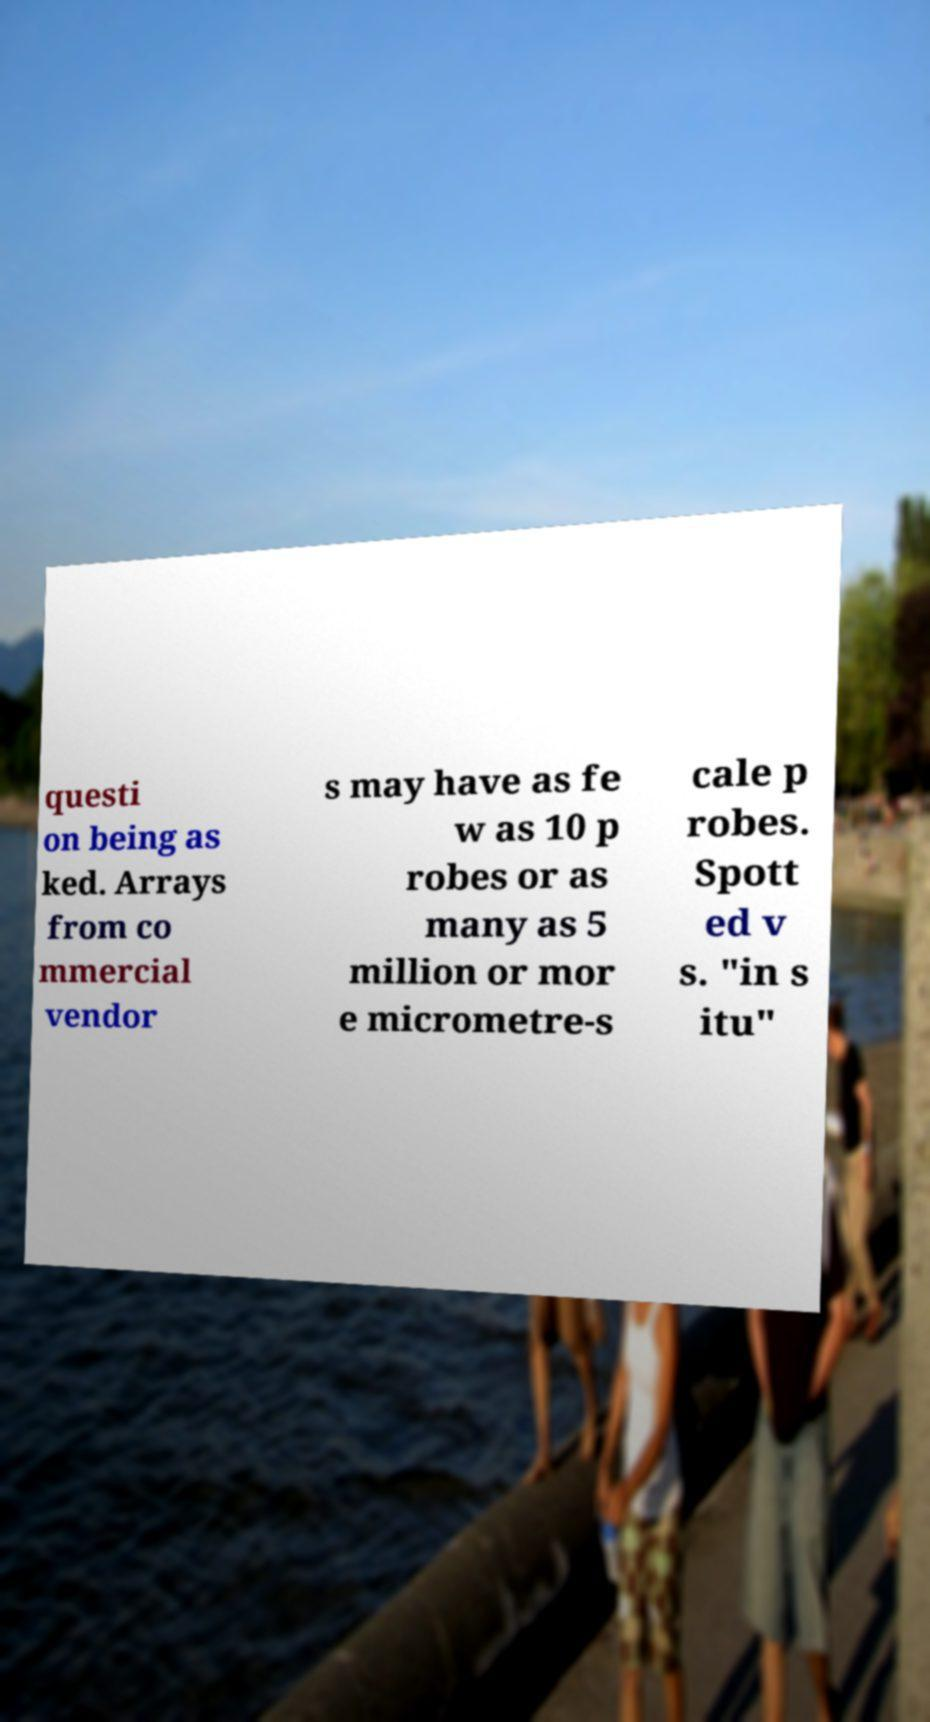Can you accurately transcribe the text from the provided image for me? questi on being as ked. Arrays from co mmercial vendor s may have as fe w as 10 p robes or as many as 5 million or mor e micrometre-s cale p robes. Spott ed v s. "in s itu" 